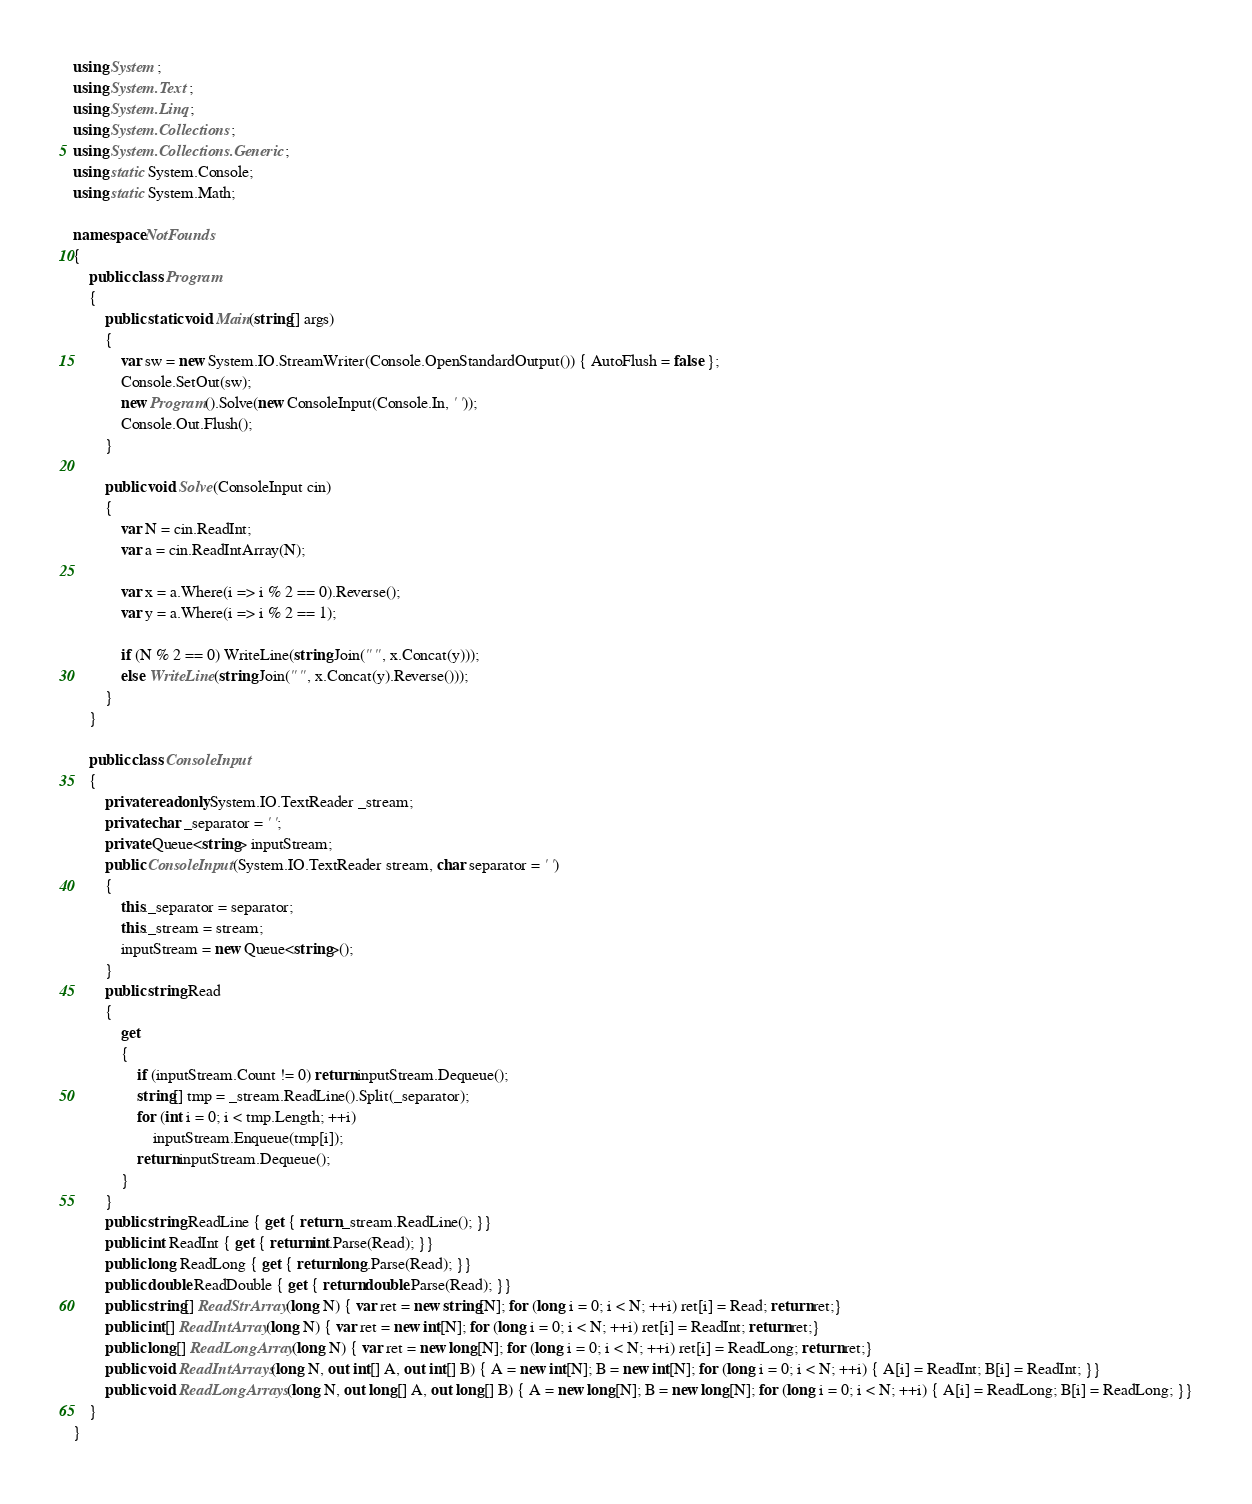<code> <loc_0><loc_0><loc_500><loc_500><_C#_>using System;
using System.Text;
using System.Linq;
using System.Collections;
using System.Collections.Generic;
using static System.Console;
using static System.Math;

namespace NotFounds
{
    public class Program
    {
        public static void Main(string[] args)
        {
            var sw = new System.IO.StreamWriter(Console.OpenStandardOutput()) { AutoFlush = false };
            Console.SetOut(sw);
            new Program().Solve(new ConsoleInput(Console.In, ' '));
            Console.Out.Flush();
        }

        public void Solve(ConsoleInput cin)
        {
            var N = cin.ReadInt;
            var a = cin.ReadIntArray(N);

            var x = a.Where(i => i % 2 == 0).Reverse();
            var y = a.Where(i => i % 2 == 1);

            if (N % 2 == 0) WriteLine(string.Join(" ", x.Concat(y)));
            else WriteLine(string.Join(" ", x.Concat(y).Reverse()));
        }
    }

    public class ConsoleInput
    {
        private readonly System.IO.TextReader _stream;
        private char _separator = ' ';
        private Queue<string> inputStream;
        public ConsoleInput(System.IO.TextReader stream, char separator = ' ')
        {
            this._separator = separator;
            this._stream = stream;
            inputStream = new Queue<string>();
        }
        public string Read
        {
            get
            {
                if (inputStream.Count != 0) return inputStream.Dequeue();
                string[] tmp = _stream.ReadLine().Split(_separator);
                for (int i = 0; i < tmp.Length; ++i)
                    inputStream.Enqueue(tmp[i]);
                return inputStream.Dequeue();
            }
        }
        public string ReadLine { get { return _stream.ReadLine(); }}
        public int ReadInt { get { return int.Parse(Read); }}
        public long ReadLong { get { return long.Parse(Read); }}
        public double ReadDouble { get { return double.Parse(Read); }}
        public string[] ReadStrArray(long N) { var ret = new string[N]; for (long i = 0; i < N; ++i) ret[i] = Read; return ret;}
        public int[] ReadIntArray(long N) { var ret = new int[N]; for (long i = 0; i < N; ++i) ret[i] = ReadInt; return ret;}
        public long[] ReadLongArray(long N) { var ret = new long[N]; for (long i = 0; i < N; ++i) ret[i] = ReadLong; return ret;}
        public void ReadIntArrays(long N, out int[] A, out int[] B) { A = new int[N]; B = new int[N]; for (long i = 0; i < N; ++i) { A[i] = ReadInt; B[i] = ReadInt; }}
        public void ReadLongArrays(long N, out long[] A, out long[] B) { A = new long[N]; B = new long[N]; for (long i = 0; i < N; ++i) { A[i] = ReadLong; B[i] = ReadLong; }}
    }
}
</code> 